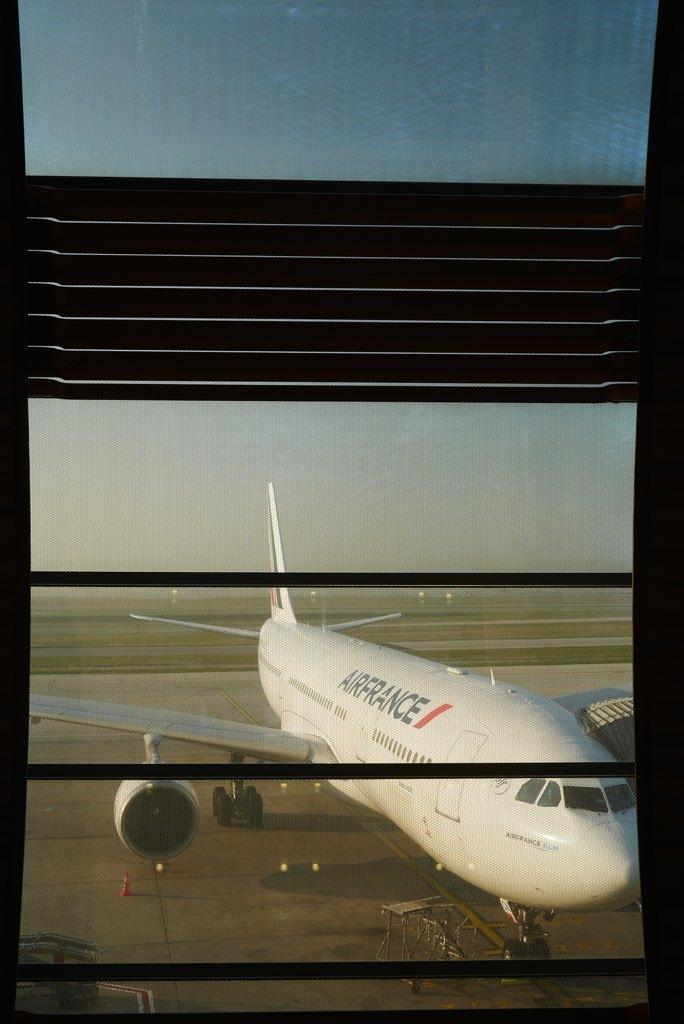<image>
Describe the image concisely. An AirFrance plane is parked on the empty runaway. 